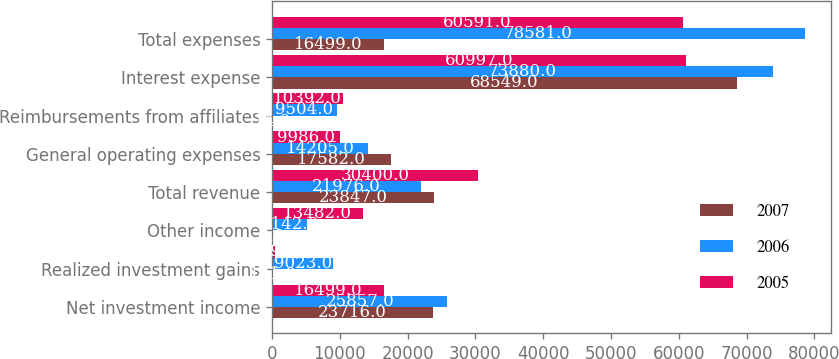Convert chart to OTSL. <chart><loc_0><loc_0><loc_500><loc_500><stacked_bar_chart><ecel><fcel>Net investment income<fcel>Realized investment gains<fcel>Other income<fcel>Total revenue<fcel>General operating expenses<fcel>Reimbursements from affiliates<fcel>Interest expense<fcel>Total expenses<nl><fcel>2007<fcel>23716<fcel>131<fcel>0<fcel>23847<fcel>17582<fcel>14<fcel>68549<fcel>16499<nl><fcel>2006<fcel>25857<fcel>9023<fcel>5142<fcel>21976<fcel>14205<fcel>9504<fcel>73880<fcel>78581<nl><fcel>2005<fcel>16499<fcel>419<fcel>13482<fcel>30400<fcel>9986<fcel>10392<fcel>60997<fcel>60591<nl></chart> 